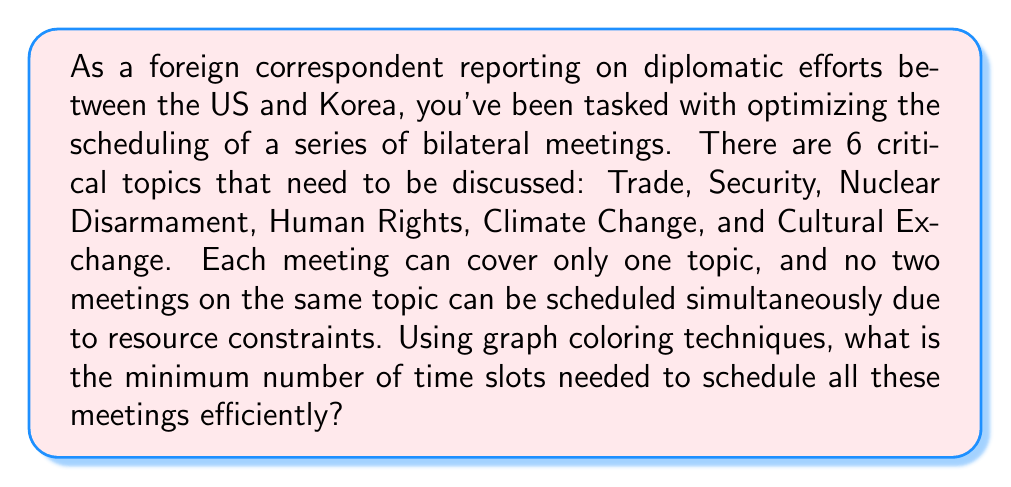Could you help me with this problem? To solve this problem using graph coloring techniques, we can follow these steps:

1. Construct a graph where each vertex represents a meeting topic, and edges connect topics that cannot be scheduled simultaneously.

2. In this case, since no two meetings on the same topic can be scheduled simultaneously, we have a complete graph with 6 vertices.

3. The chromatic number of a complete graph with n vertices is always n. This is because each vertex must have a different color from all others.

4. In graph coloring, each color represents a time slot. The chromatic number represents the minimum number of colors (time slots) needed to color all vertices (schedule all meetings) without adjacent vertices having the same color.

5. For a complete graph with 6 vertices:

   $$\chi(K_6) = 6$$

   where $\chi$ represents the chromatic number and $K_6$ is a complete graph with 6 vertices.

6. Therefore, the minimum number of time slots needed to schedule all these meetings efficiently is 6.

This solution ensures that all topics are covered, and no two meetings on the same topic are scheduled simultaneously, optimizing the diplomatic meeting schedule.
Answer: 6 time slots 